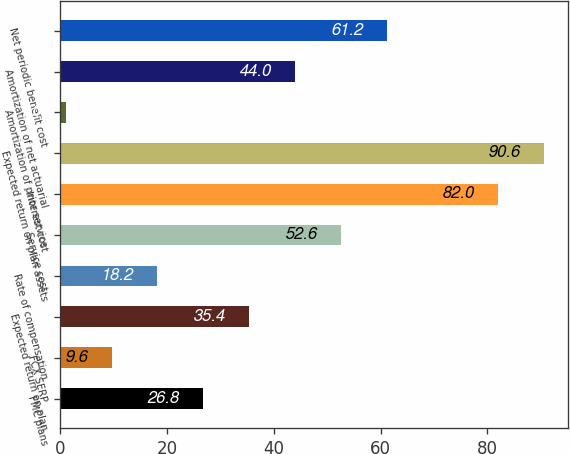<chart> <loc_0><loc_0><loc_500><loc_500><bar_chart><fcel>FMC plans<fcel>FCX SERP<fcel>Expected return on plan<fcel>Rate of compensation<fcel>Service cost<fcel>Interest cost<fcel>Expected return on plan assets<fcel>Amortization of prior service<fcel>Amortization of net actuarial<fcel>Net periodic benefit cost<nl><fcel>26.8<fcel>9.6<fcel>35.4<fcel>18.2<fcel>52.6<fcel>82<fcel>90.6<fcel>1<fcel>44<fcel>61.2<nl></chart> 